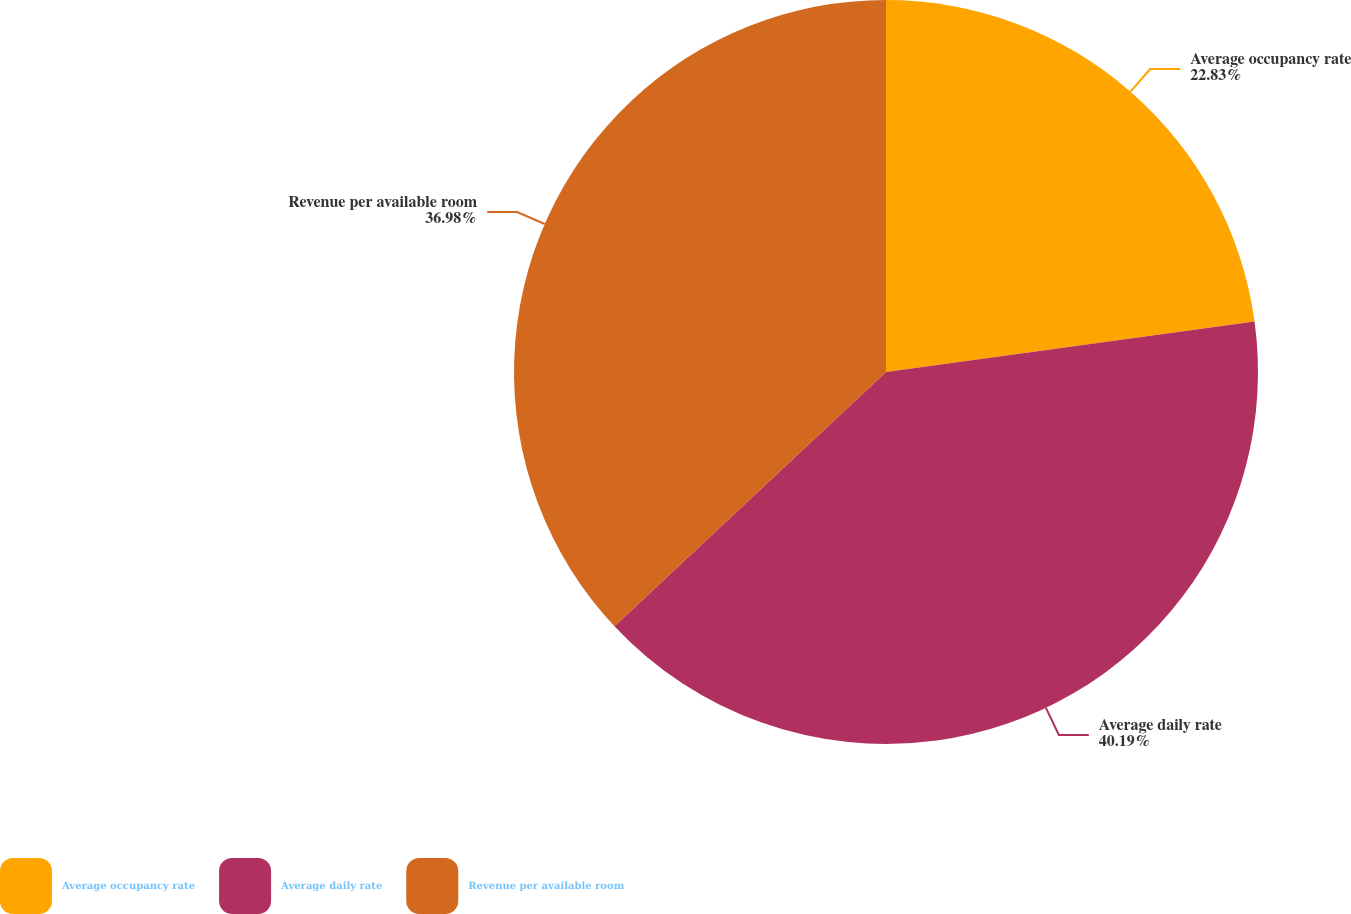<chart> <loc_0><loc_0><loc_500><loc_500><pie_chart><fcel>Average occupancy rate<fcel>Average daily rate<fcel>Revenue per available room<nl><fcel>22.83%<fcel>40.2%<fcel>36.98%<nl></chart> 